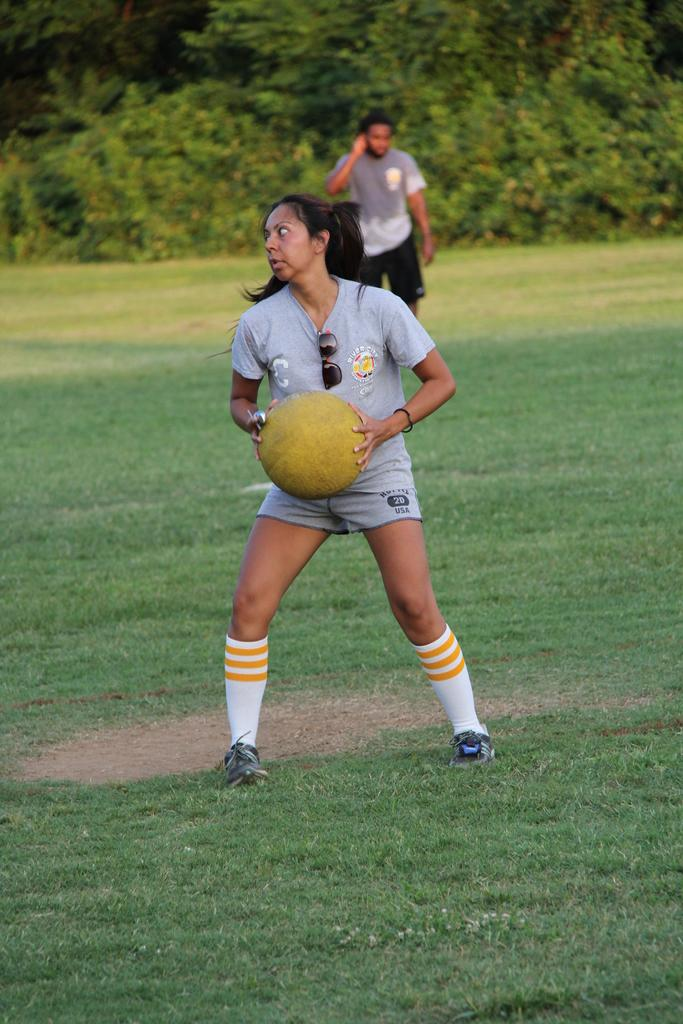Who is present in the image? There is a woman and a man in the image. What is the woman holding in her hand? The woman is holding a ball in her hand. Where is the man positioned in relation to the woman? The man is on the back, presumably behind the woman. What type of natural environment can be seen in the image? There are trees visible in the image. What type of soda is the woman drinking in the image? There is no soda present in the image; the woman is holding a ball. Can you tell me how many quartz rocks are visible in the image? There is no quartz present in the image; only a woman, a man, a ball, and trees are visible. 